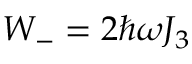Convert formula to latex. <formula><loc_0><loc_0><loc_500><loc_500>W _ { - } = 2 \hbar { \omega } J _ { 3 }</formula> 